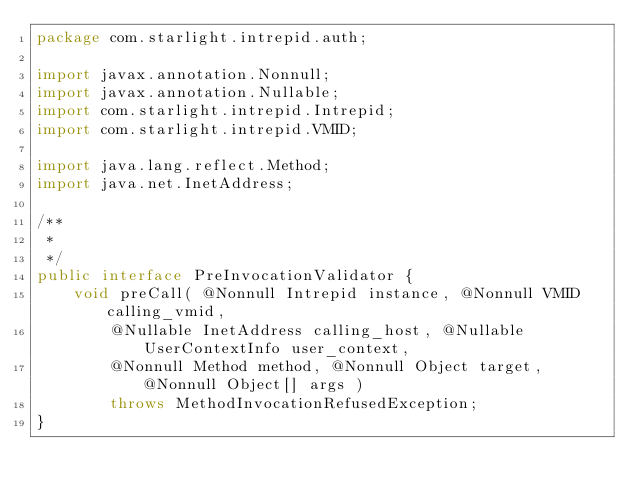<code> <loc_0><loc_0><loc_500><loc_500><_Java_>package com.starlight.intrepid.auth;

import javax.annotation.Nonnull;
import javax.annotation.Nullable;
import com.starlight.intrepid.Intrepid;
import com.starlight.intrepid.VMID;

import java.lang.reflect.Method;
import java.net.InetAddress;

/**
 *
 */
public interface PreInvocationValidator {
	void preCall( @Nonnull Intrepid instance, @Nonnull VMID calling_vmid,
		@Nullable InetAddress calling_host, @Nullable UserContextInfo user_context,
		@Nonnull Method method, @Nonnull Object target, @Nonnull Object[] args )
		throws MethodInvocationRefusedException;
}
</code> 